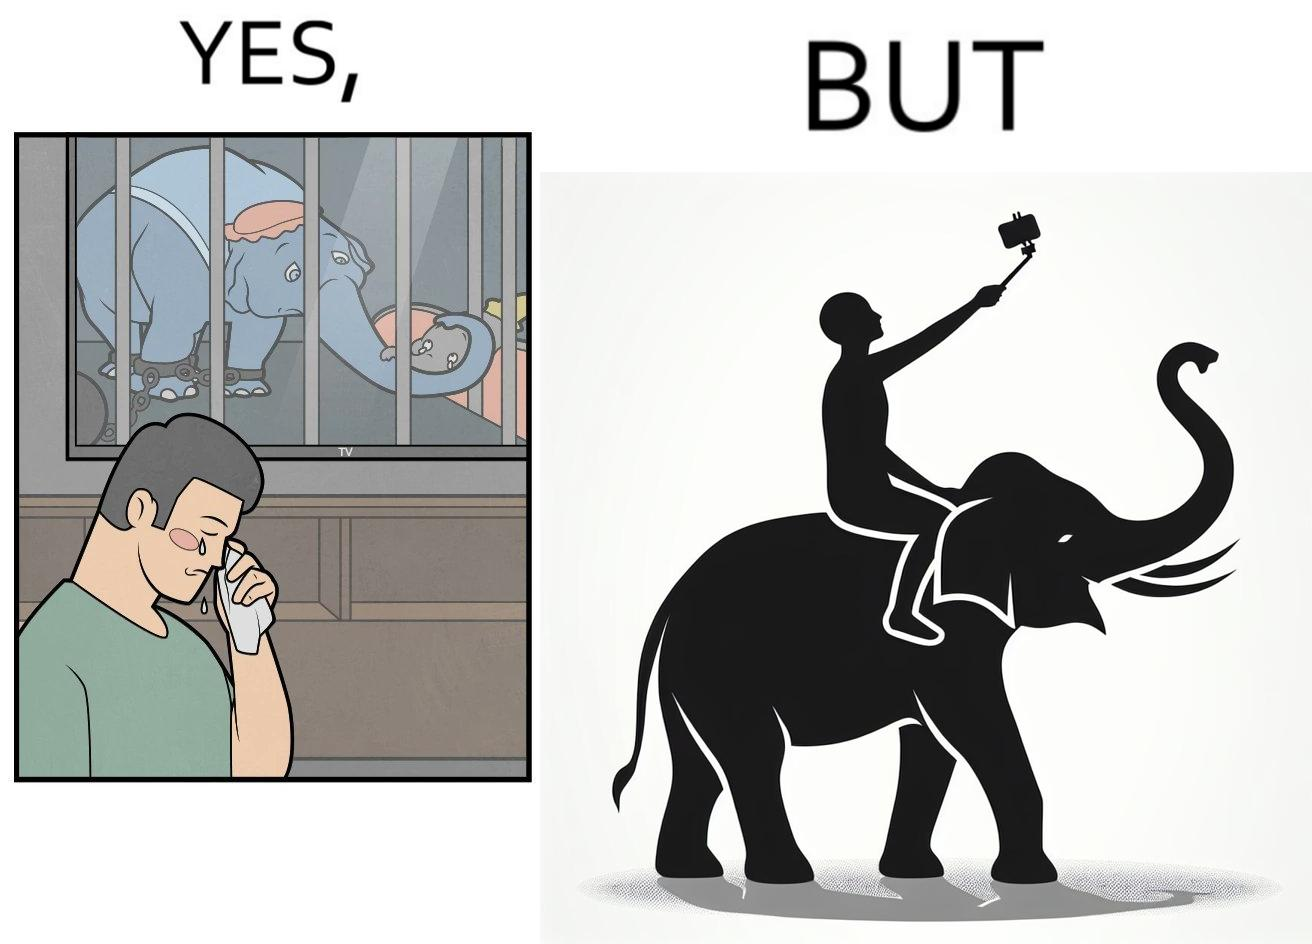What is the satirical meaning behind this image? The image is ironic, because the people who get sentimental over imprisoned animal while watching TV shows often feel okay when using animals for labor 